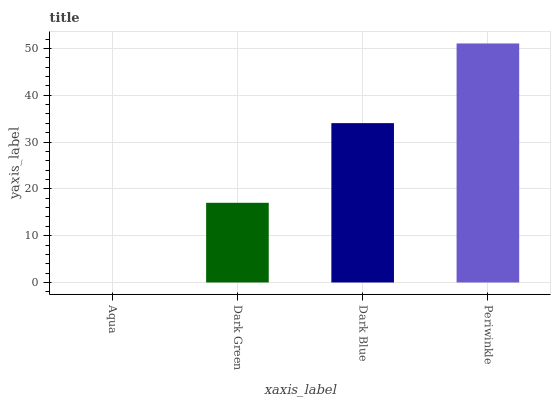Is Aqua the minimum?
Answer yes or no. Yes. Is Periwinkle the maximum?
Answer yes or no. Yes. Is Dark Green the minimum?
Answer yes or no. No. Is Dark Green the maximum?
Answer yes or no. No. Is Dark Green greater than Aqua?
Answer yes or no. Yes. Is Aqua less than Dark Green?
Answer yes or no. Yes. Is Aqua greater than Dark Green?
Answer yes or no. No. Is Dark Green less than Aqua?
Answer yes or no. No. Is Dark Blue the high median?
Answer yes or no. Yes. Is Dark Green the low median?
Answer yes or no. Yes. Is Aqua the high median?
Answer yes or no. No. Is Aqua the low median?
Answer yes or no. No. 